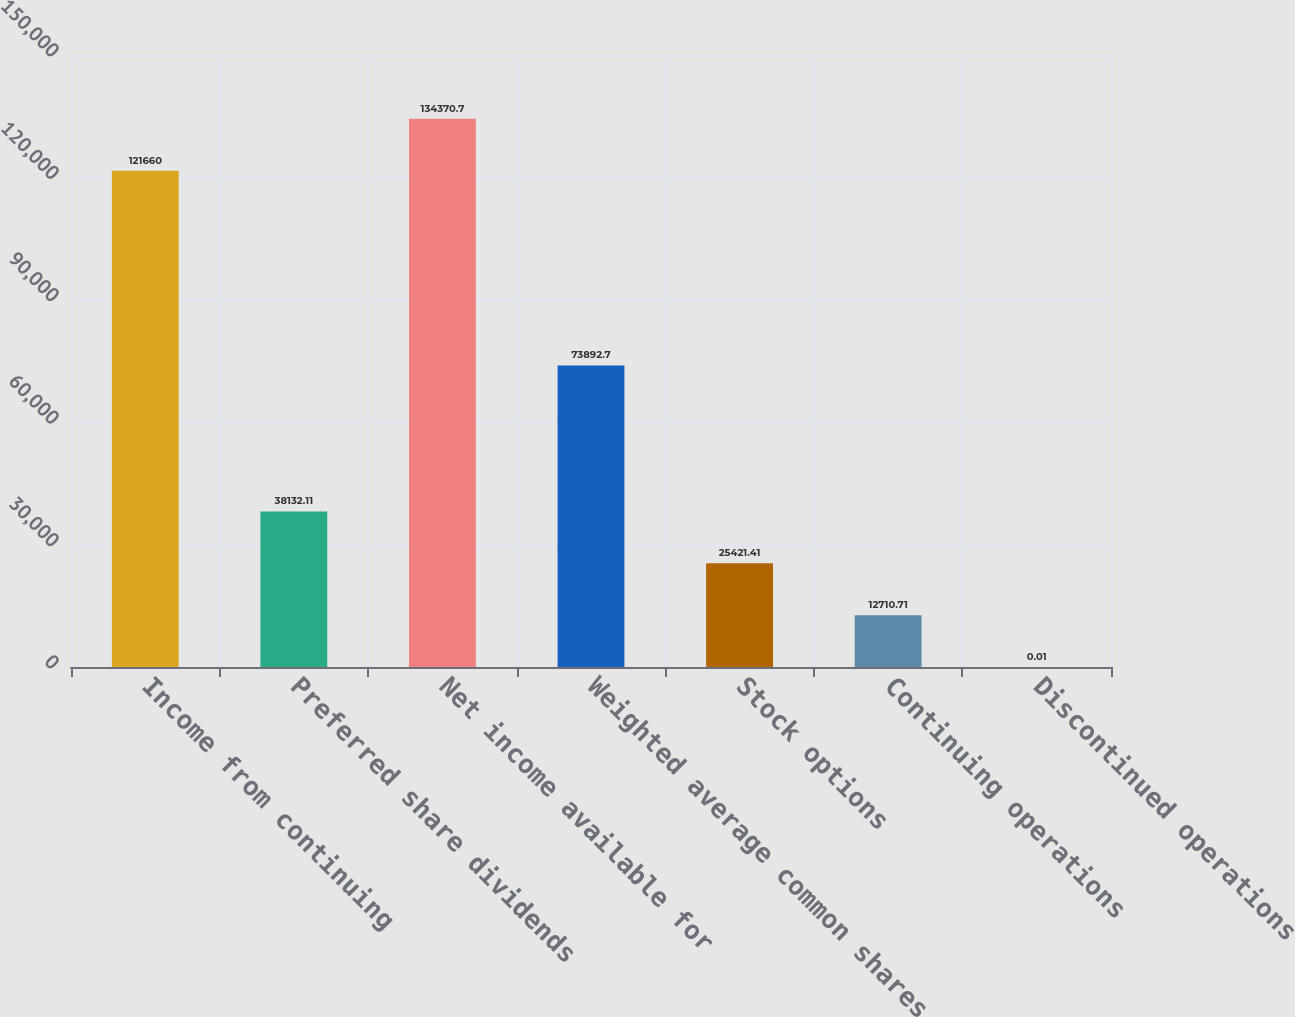<chart> <loc_0><loc_0><loc_500><loc_500><bar_chart><fcel>Income from continuing<fcel>Preferred share dividends<fcel>Net income available for<fcel>Weighted average common shares<fcel>Stock options<fcel>Continuing operations<fcel>Discontinued operations<nl><fcel>121660<fcel>38132.1<fcel>134371<fcel>73892.7<fcel>25421.4<fcel>12710.7<fcel>0.01<nl></chart> 